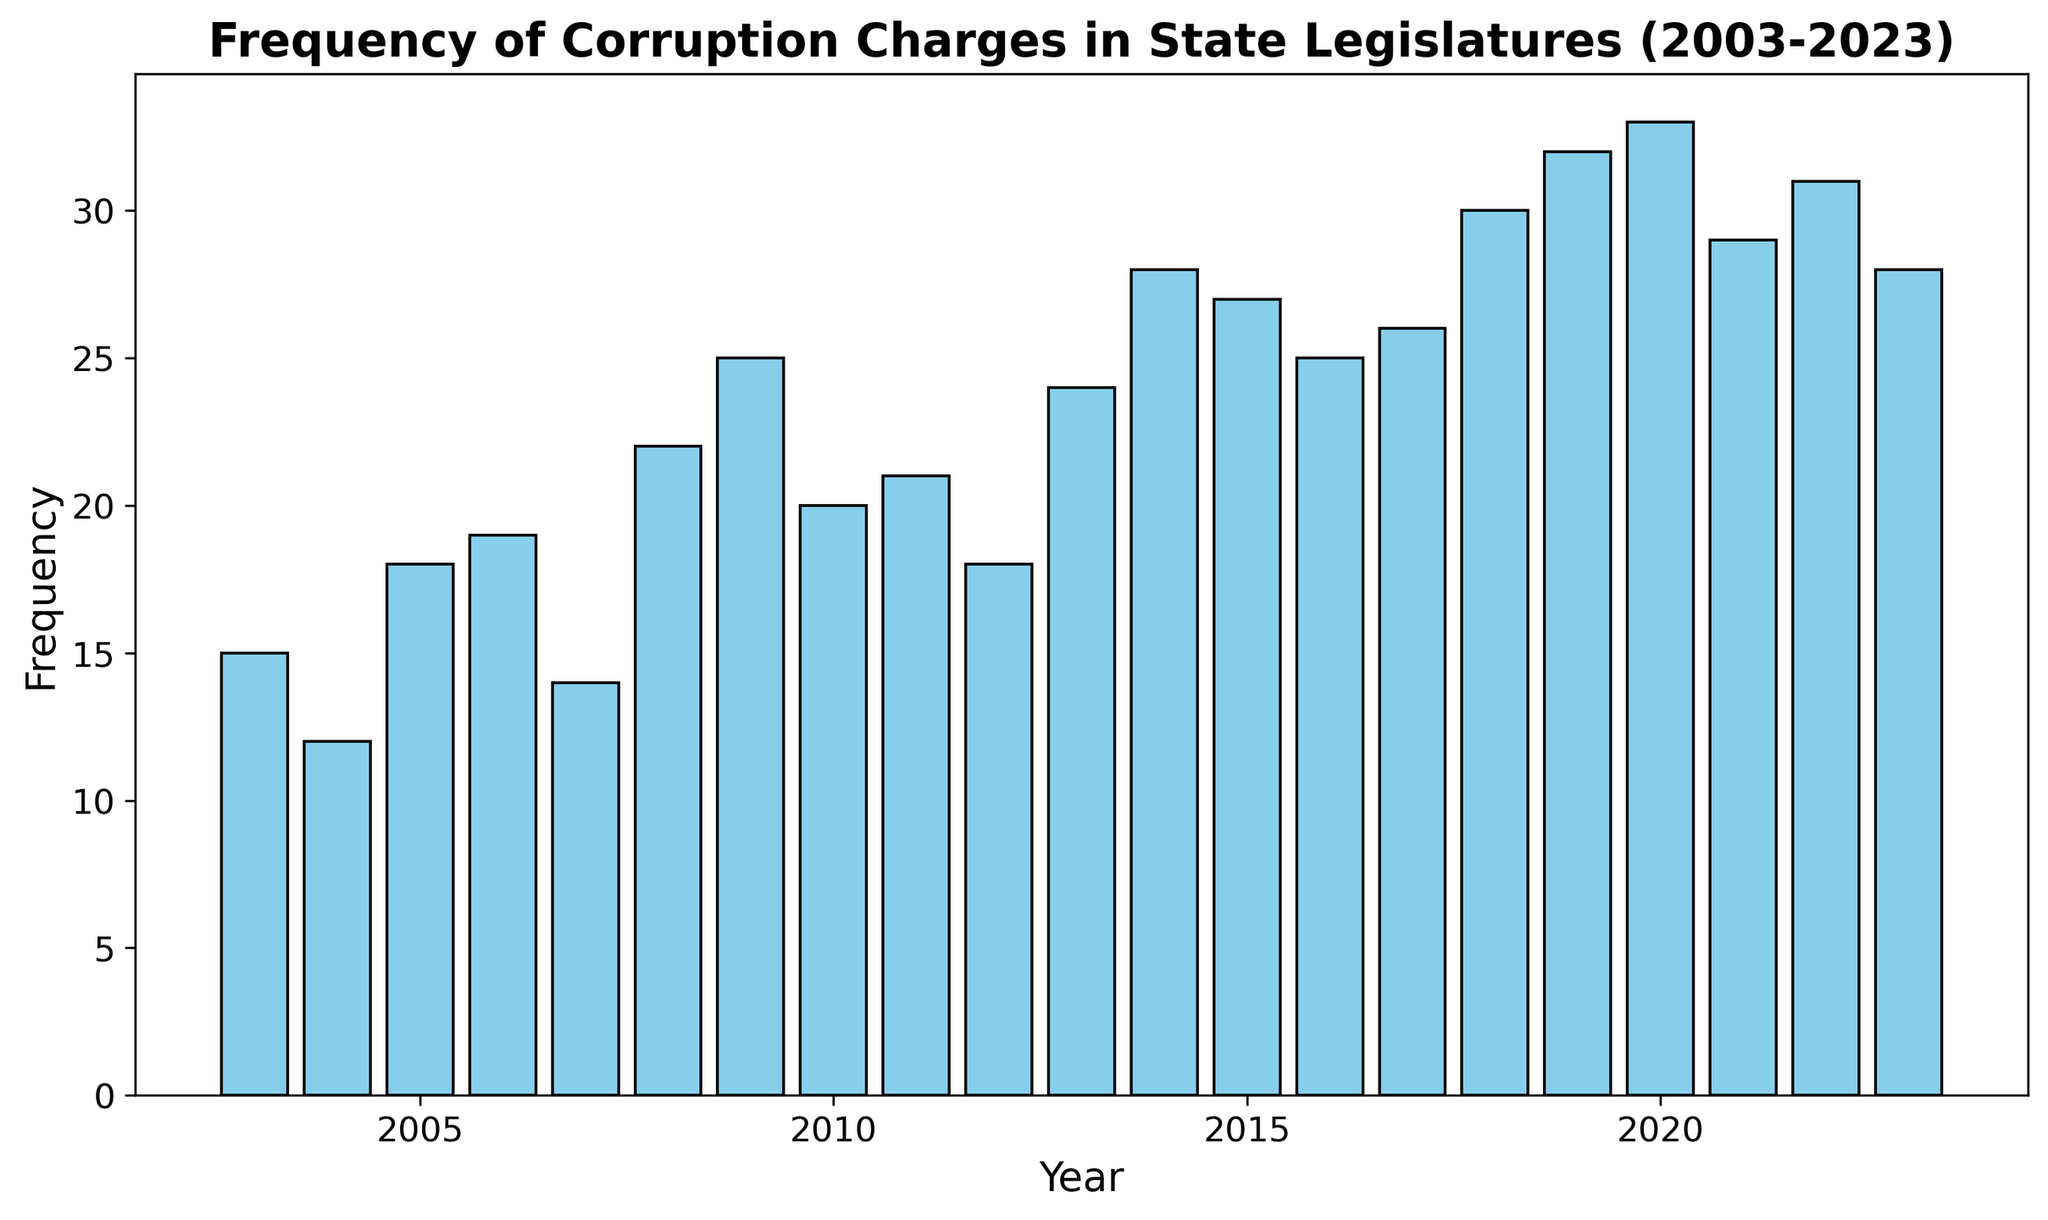What is the highest frequency of corruption charges reported in any year? Identify the tallest bar in the histogram, which represents the highest frequency. The bar for the year 2020 reaches the highest point.
Answer: 33 What is the average frequency of corruption charges over the 20-year period? Add up all the frequencies from 2003 to 2023: 15 + 12 + 18 + 19 + 14 + 22 + 25 + 20 + 21 + 18 + 24 + 28 + 27 + 25 + 26 + 30 + 32 + 33 + 29 + 31 + 28 = 457. The period spans 21 years. So, the average is 457 / 21 ≈ 21.76.
Answer: 21.76 Which year saw the biggest increase in the frequency of corruption charges from the previous year? Calculate the difference in frequency from year to year and identify the largest positive difference: between 2008 (22) and 2009 (25); the increase is 25 - 22 = 3. Other differences are smaller.
Answer: 2008 to 2009 In which year(s) was the frequency exactly 25? Look for the bars that reach up to the 25 mark on the y-axis. Check the corresponding year labels: 2009, 2016, and 2017.
Answer: 2009, 2016, and 2017 How many years had a frequency greater than 25? Count the bars that exceed the 25 mark on the y-axis. These correspond to the years 2018 (30), 2019 (32), 2020 (33), 2021 (29), and 2022 (31). Total: 5 years.
Answer: 5 What is the median frequency of corruption charges across the entire dataset? Arrange the frequencies in numerical order and identify the middle value in the ordered list. The sorted frequencies are: 12, 14, 15, 18, 18, 19, 20, 21, 22, 24, 25, 25, 26, 27, 28, 28, 29, 30, 31, 32, 33. The middle value (11th in the list) is 25.
Answer: 25 Compare the frequency of corruption charges in 2003 and 2023. Which year had a higher frequency? Look at the heights of the bars for the years 2003 and 2023. The bar for 2023 is higher than the bar for 2003. 2023 has 28, while 2003 has 15.
Answer: 2023 What was the total sum of the frequencies of corruption charges from 2015 to 2020? Add the frequencies for each year from 2015 to 2020: 27 (2015) + 25 (2016) + 26 (2017) + 30 (2018) + 32 (2019) + 33 (2020). The total is 173.
Answer: 173 What is the most frequent range of corruption charges in the dataset, 15-20 or 25-30? Count the number of years each frequency range appears in the data. For the range 15-20: 2003 (15), 2004 (12), 2005 (18), 2006 (19), 2007 (14), 2012 (18). Total = 6. For the range 25-30: 2009 (25), 2013 (24), 2015 (27), 2016 (25), 2017 (26), 2018 (30). Total = 6.
Answer: Both ranges (15-20 and 25-30) have the same frequency (6 years each) In what year did the frequency of corruption charges first exceed 25? Identify the first year where the bar's height is above the 25 mark. The year 2013 has 24, so the first year where it exceeds 25 is 2014.
Answer: 2014 